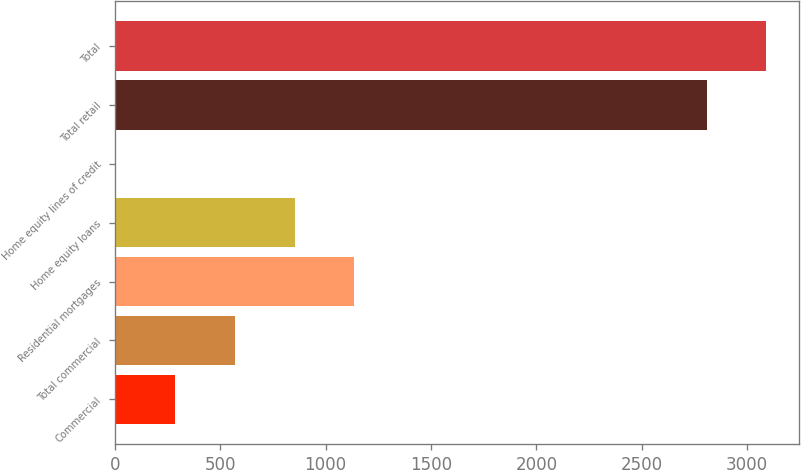Convert chart. <chart><loc_0><loc_0><loc_500><loc_500><bar_chart><fcel>Commercial<fcel>Total commercial<fcel>Residential mortgages<fcel>Home equity loans<fcel>Home equity lines of credit<fcel>Total retail<fcel>Total<nl><fcel>287<fcel>570<fcel>1136<fcel>853<fcel>4<fcel>2808<fcel>3091<nl></chart> 